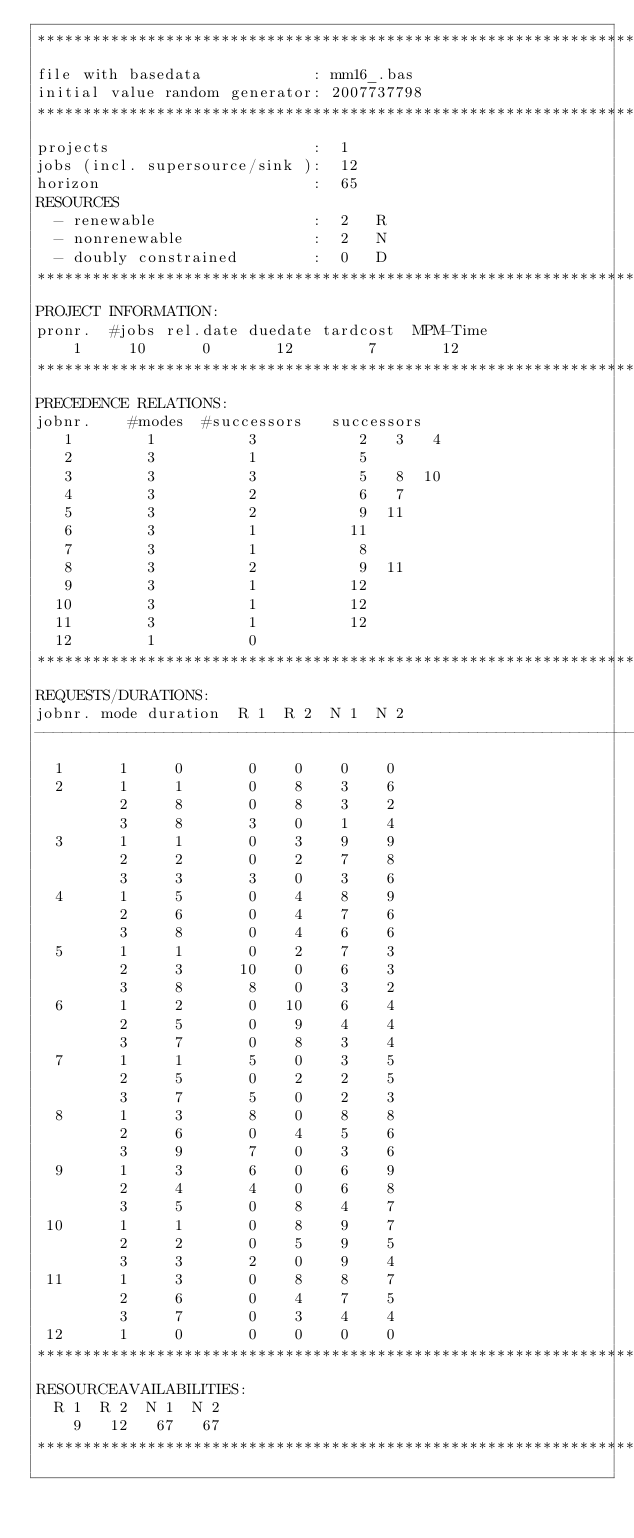Convert code to text. <code><loc_0><loc_0><loc_500><loc_500><_ObjectiveC_>************************************************************************
file with basedata            : mm16_.bas
initial value random generator: 2007737798
************************************************************************
projects                      :  1
jobs (incl. supersource/sink ):  12
horizon                       :  65
RESOURCES
  - renewable                 :  2   R
  - nonrenewable              :  2   N
  - doubly constrained        :  0   D
************************************************************************
PROJECT INFORMATION:
pronr.  #jobs rel.date duedate tardcost  MPM-Time
    1     10      0       12        7       12
************************************************************************
PRECEDENCE RELATIONS:
jobnr.    #modes  #successors   successors
   1        1          3           2   3   4
   2        3          1           5
   3        3          3           5   8  10
   4        3          2           6   7
   5        3          2           9  11
   6        3          1          11
   7        3          1           8
   8        3          2           9  11
   9        3          1          12
  10        3          1          12
  11        3          1          12
  12        1          0        
************************************************************************
REQUESTS/DURATIONS:
jobnr. mode duration  R 1  R 2  N 1  N 2
------------------------------------------------------------------------
  1      1     0       0    0    0    0
  2      1     1       0    8    3    6
         2     8       0    8    3    2
         3     8       3    0    1    4
  3      1     1       0    3    9    9
         2     2       0    2    7    8
         3     3       3    0    3    6
  4      1     5       0    4    8    9
         2     6       0    4    7    6
         3     8       0    4    6    6
  5      1     1       0    2    7    3
         2     3      10    0    6    3
         3     8       8    0    3    2
  6      1     2       0   10    6    4
         2     5       0    9    4    4
         3     7       0    8    3    4
  7      1     1       5    0    3    5
         2     5       0    2    2    5
         3     7       5    0    2    3
  8      1     3       8    0    8    8
         2     6       0    4    5    6
         3     9       7    0    3    6
  9      1     3       6    0    6    9
         2     4       4    0    6    8
         3     5       0    8    4    7
 10      1     1       0    8    9    7
         2     2       0    5    9    5
         3     3       2    0    9    4
 11      1     3       0    8    8    7
         2     6       0    4    7    5
         3     7       0    3    4    4
 12      1     0       0    0    0    0
************************************************************************
RESOURCEAVAILABILITIES:
  R 1  R 2  N 1  N 2
    9   12   67   67
************************************************************************
</code> 